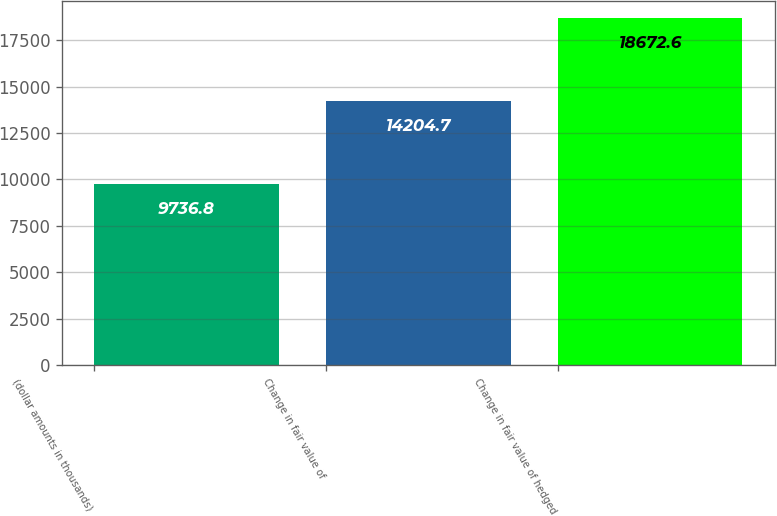Convert chart to OTSL. <chart><loc_0><loc_0><loc_500><loc_500><bar_chart><fcel>(dollar amounts in thousands)<fcel>Change in fair value of<fcel>Change in fair value of hedged<nl><fcel>9736.8<fcel>14204.7<fcel>18672.6<nl></chart> 